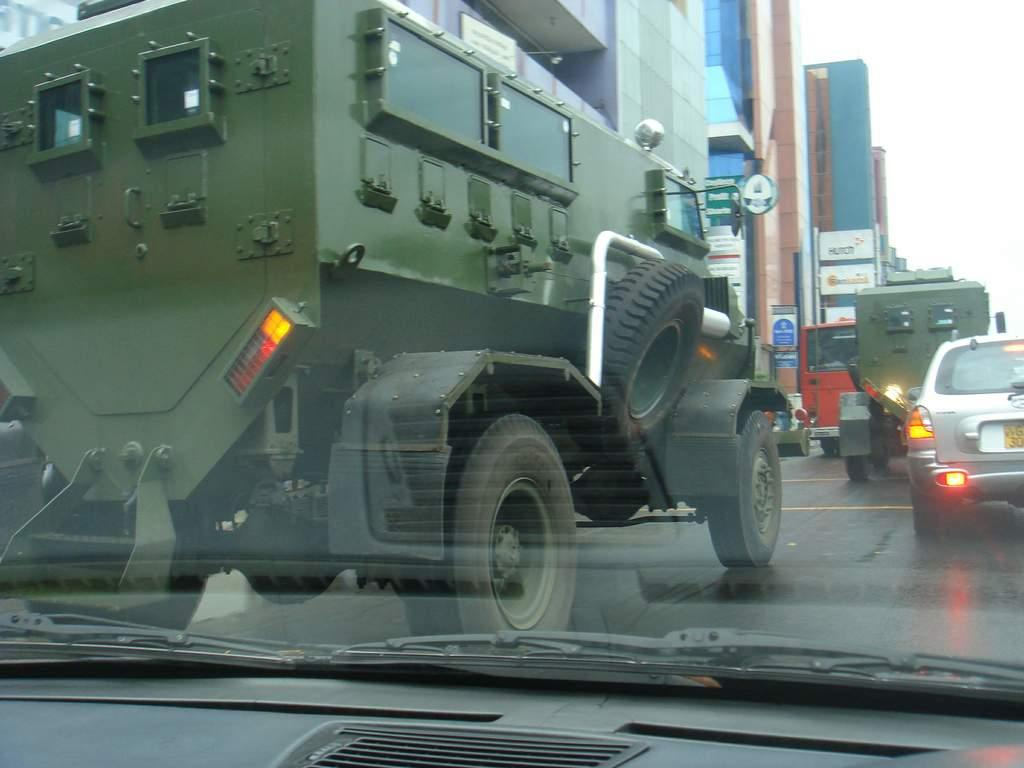What is the main subject of the image? The main subject of the image is a road. What can be seen on the road in the image? There are many vehicles on the road in the image. What specific features of the vehicles are visible in the image? The back lights and number plates of vehicles are visible in the image. What is visible in the background of the image? There are buildings in the background of the image. What is the color of the sky in the image? The sky is white in the image. Can you tell me how many tanks are visible in the image? There are no tanks present in the image. What type of cent can be seen interacting with the vehicles in the image? There is no cent present in the image; only vehicles, buildings, and the sky are visible. 